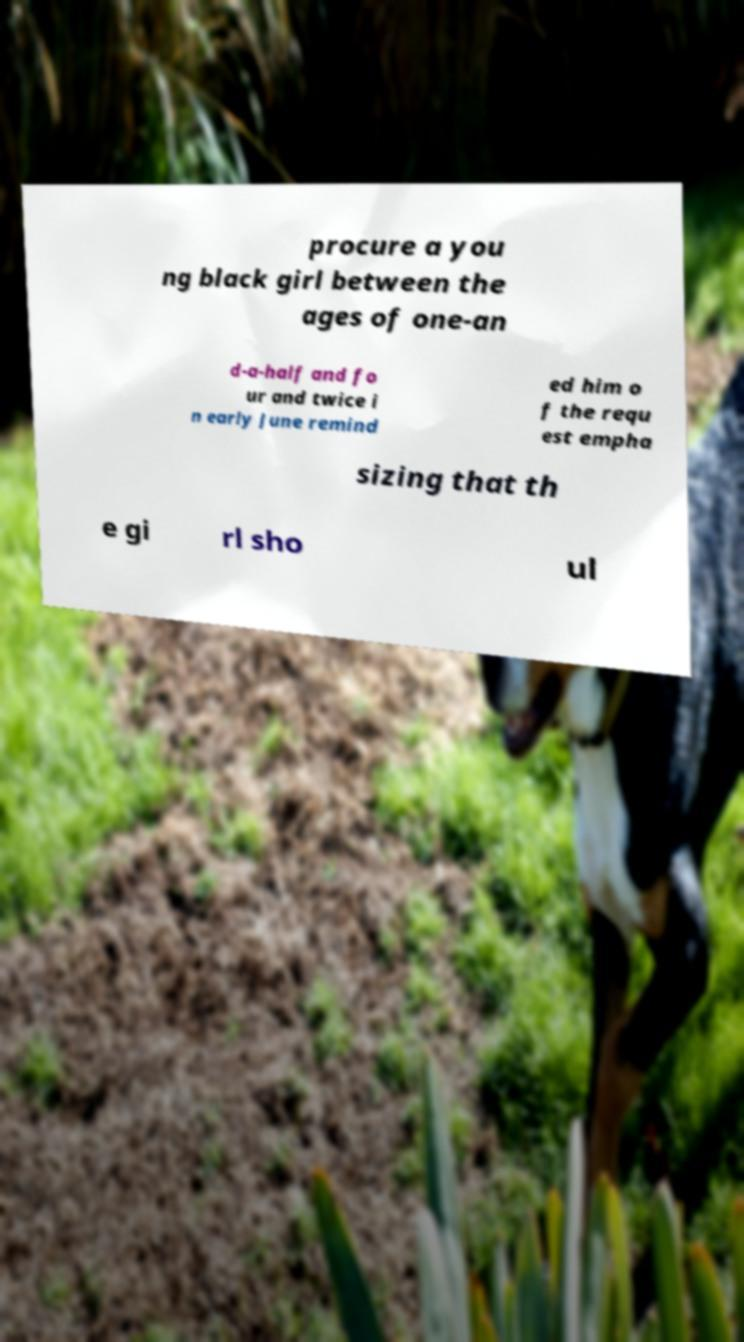Could you assist in decoding the text presented in this image and type it out clearly? procure a you ng black girl between the ages of one-an d-a-half and fo ur and twice i n early June remind ed him o f the requ est empha sizing that th e gi rl sho ul 